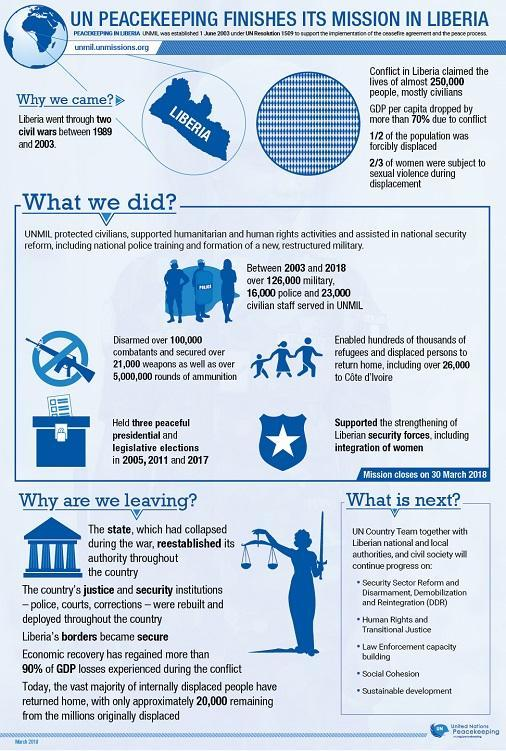How many number of people died due to the conflict in Liberia?
Answer the question with a short phrase. 250,000 How many police personnels were deployed in the UNMIL peacekeeping mission? 16,000 How many civil wars took place in Liberia between 1989 & 2003? two civil wars What was the duration of UNMIL peacekeeping mission by the UN? Between 2003 and 2018 What was the percentage decrease in GDP per capita due to conflict in Liberia? more than 70% During which years, the elections were carried out in Liberia with the support of UNMIL? in 2005, 2007 and 2017 Which peacekeeping mission was deployed in Liberia by the UN in 2003? UNMIL How many military troops were deployed in the UNMIL peacekeeping mission? over 126,000 